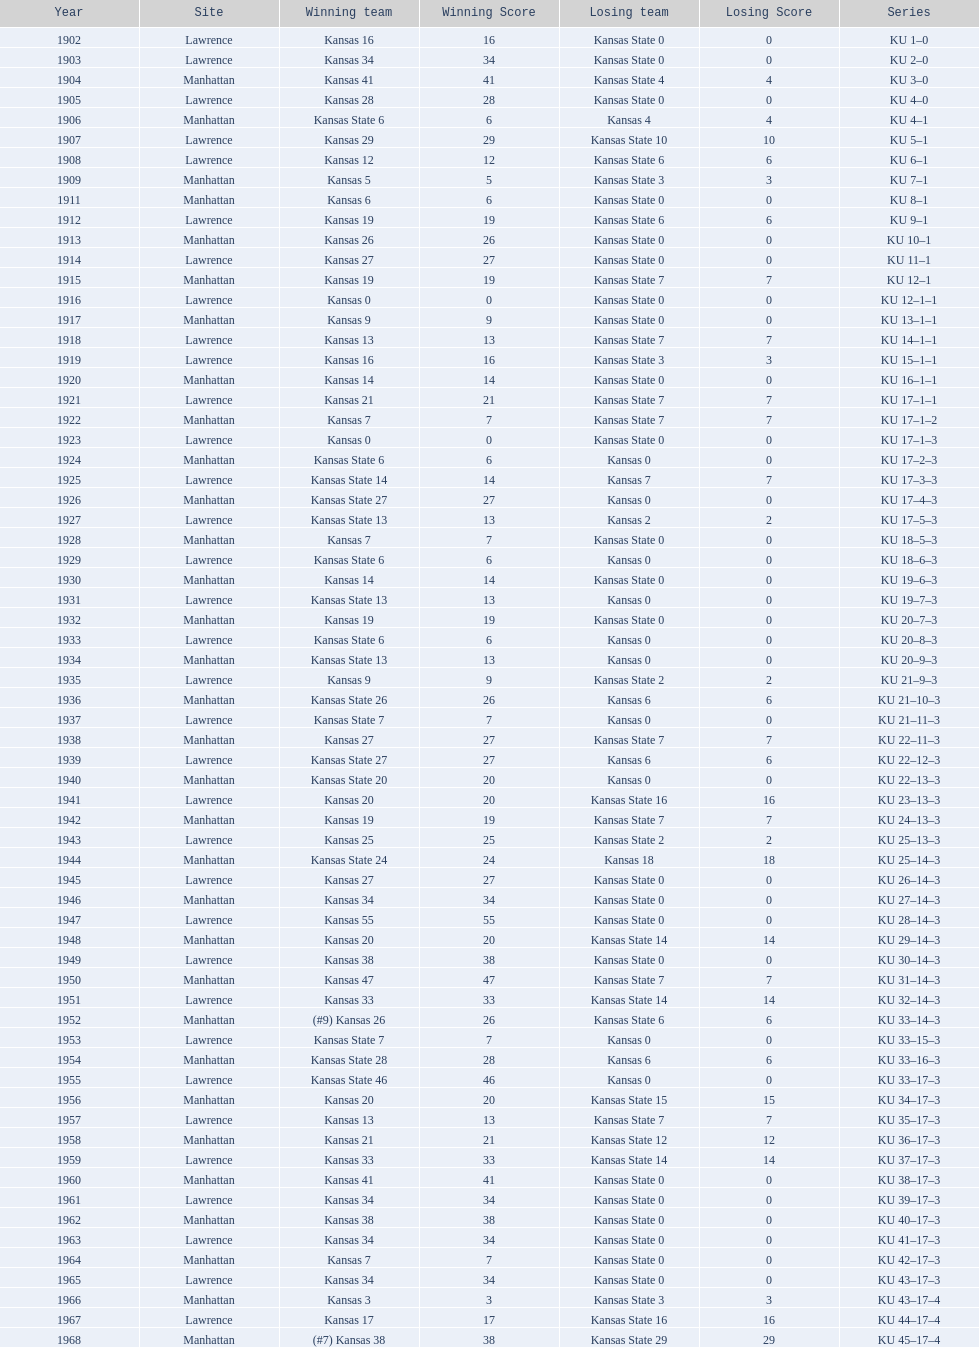How many times did kansas and kansas state play in lawrence from 1902-1968? 34. 